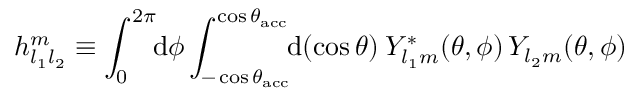Convert formula to latex. <formula><loc_0><loc_0><loc_500><loc_500>h _ { l _ { 1 } l _ { 2 } } ^ { m } \equiv \int _ { 0 } ^ { 2 \pi } \, d \phi \int _ { - \cos { \theta _ { a c c } } } ^ { \cos { \theta _ { a c c } } } \, d ( \cos { \theta } ) \, Y _ { l _ { 1 } m } ^ { * } ( \theta , \phi ) \, Y _ { l _ { 2 } m } ( \theta , \phi )</formula> 